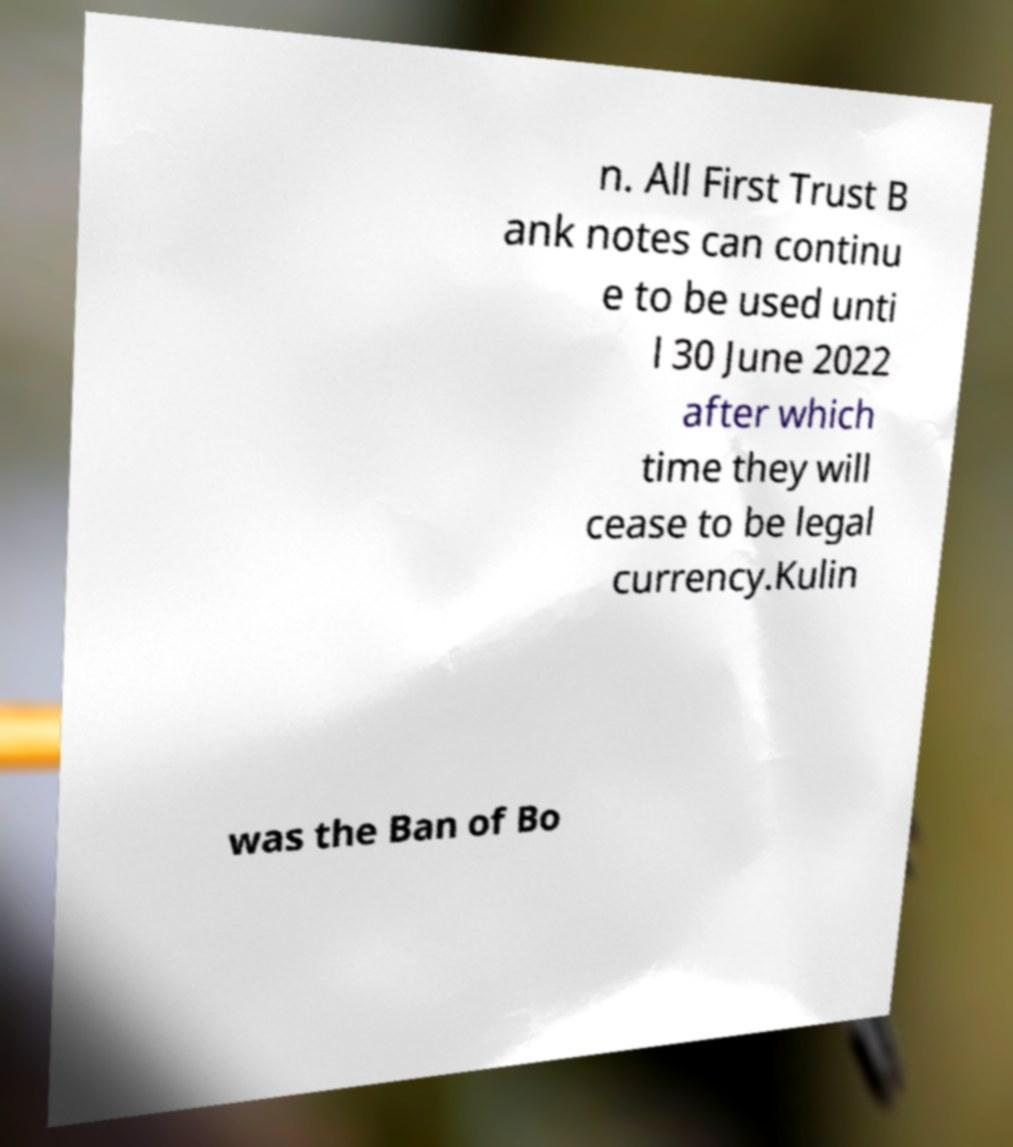Please read and relay the text visible in this image. What does it say? n. All First Trust B ank notes can continu e to be used unti l 30 June 2022 after which time they will cease to be legal currency.Kulin was the Ban of Bo 